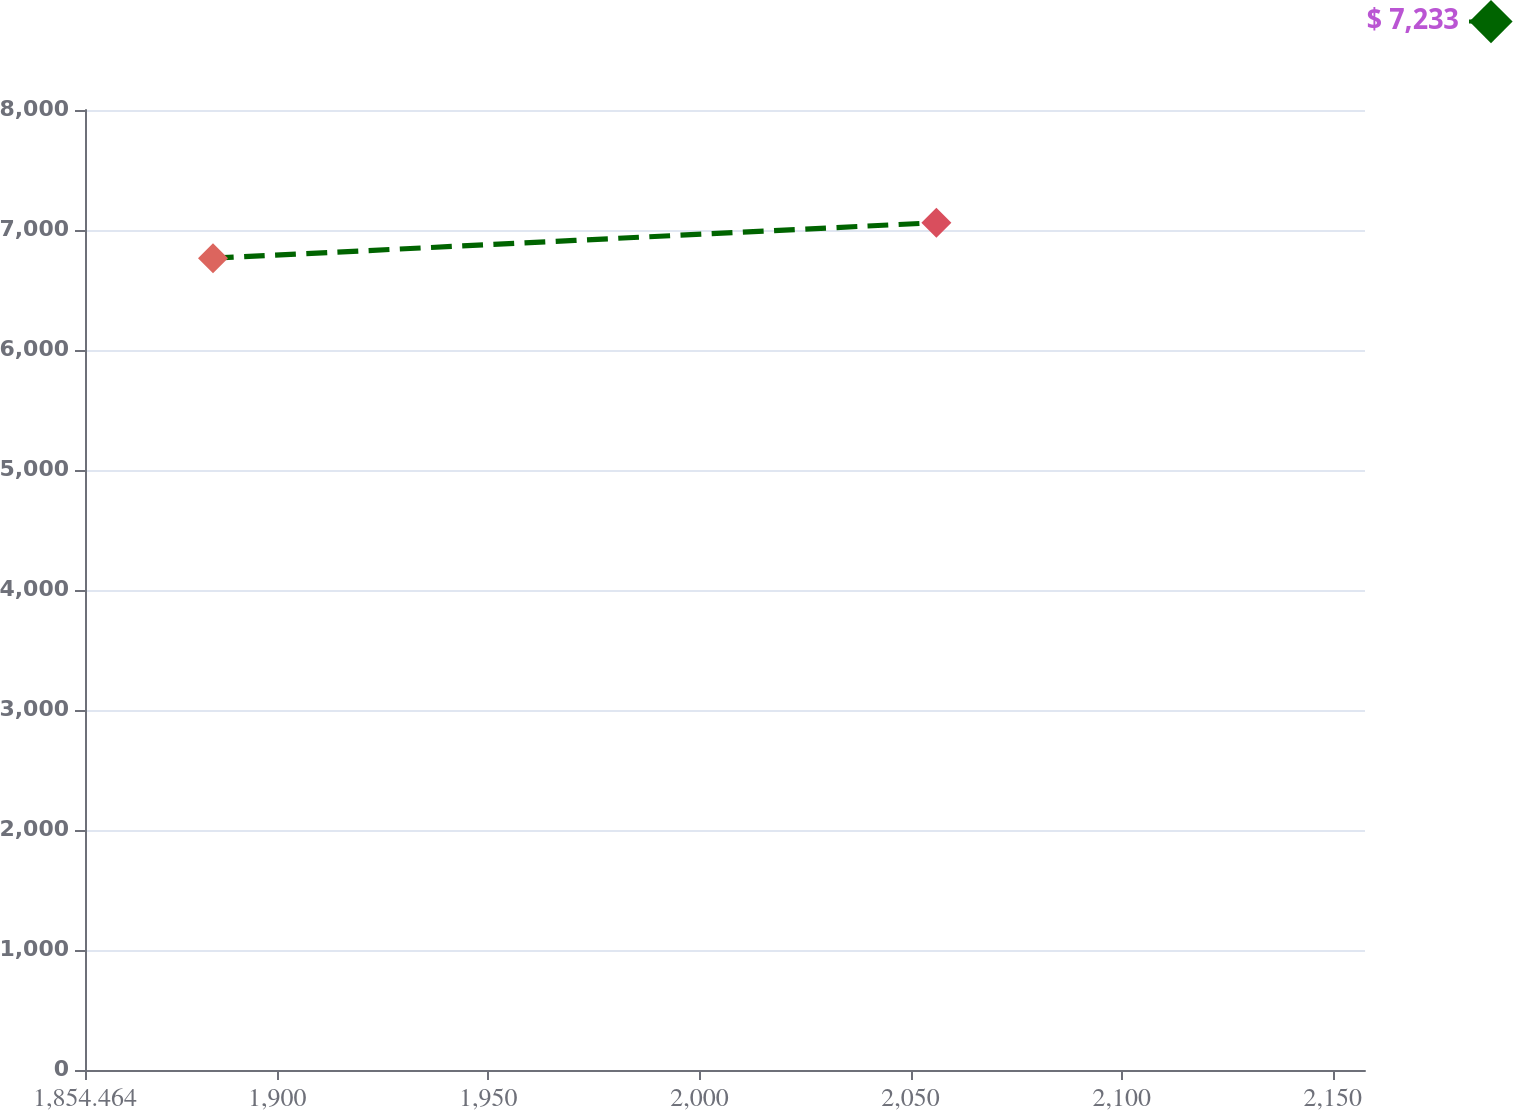<chart> <loc_0><loc_0><loc_500><loc_500><line_chart><ecel><fcel>$ 7,233<nl><fcel>1884.78<fcel>6765.06<nl><fcel>2056.11<fcel>7061.33<nl><fcel>2159.99<fcel>4400.15<nl><fcel>2187.94<fcel>3970.76<nl></chart> 